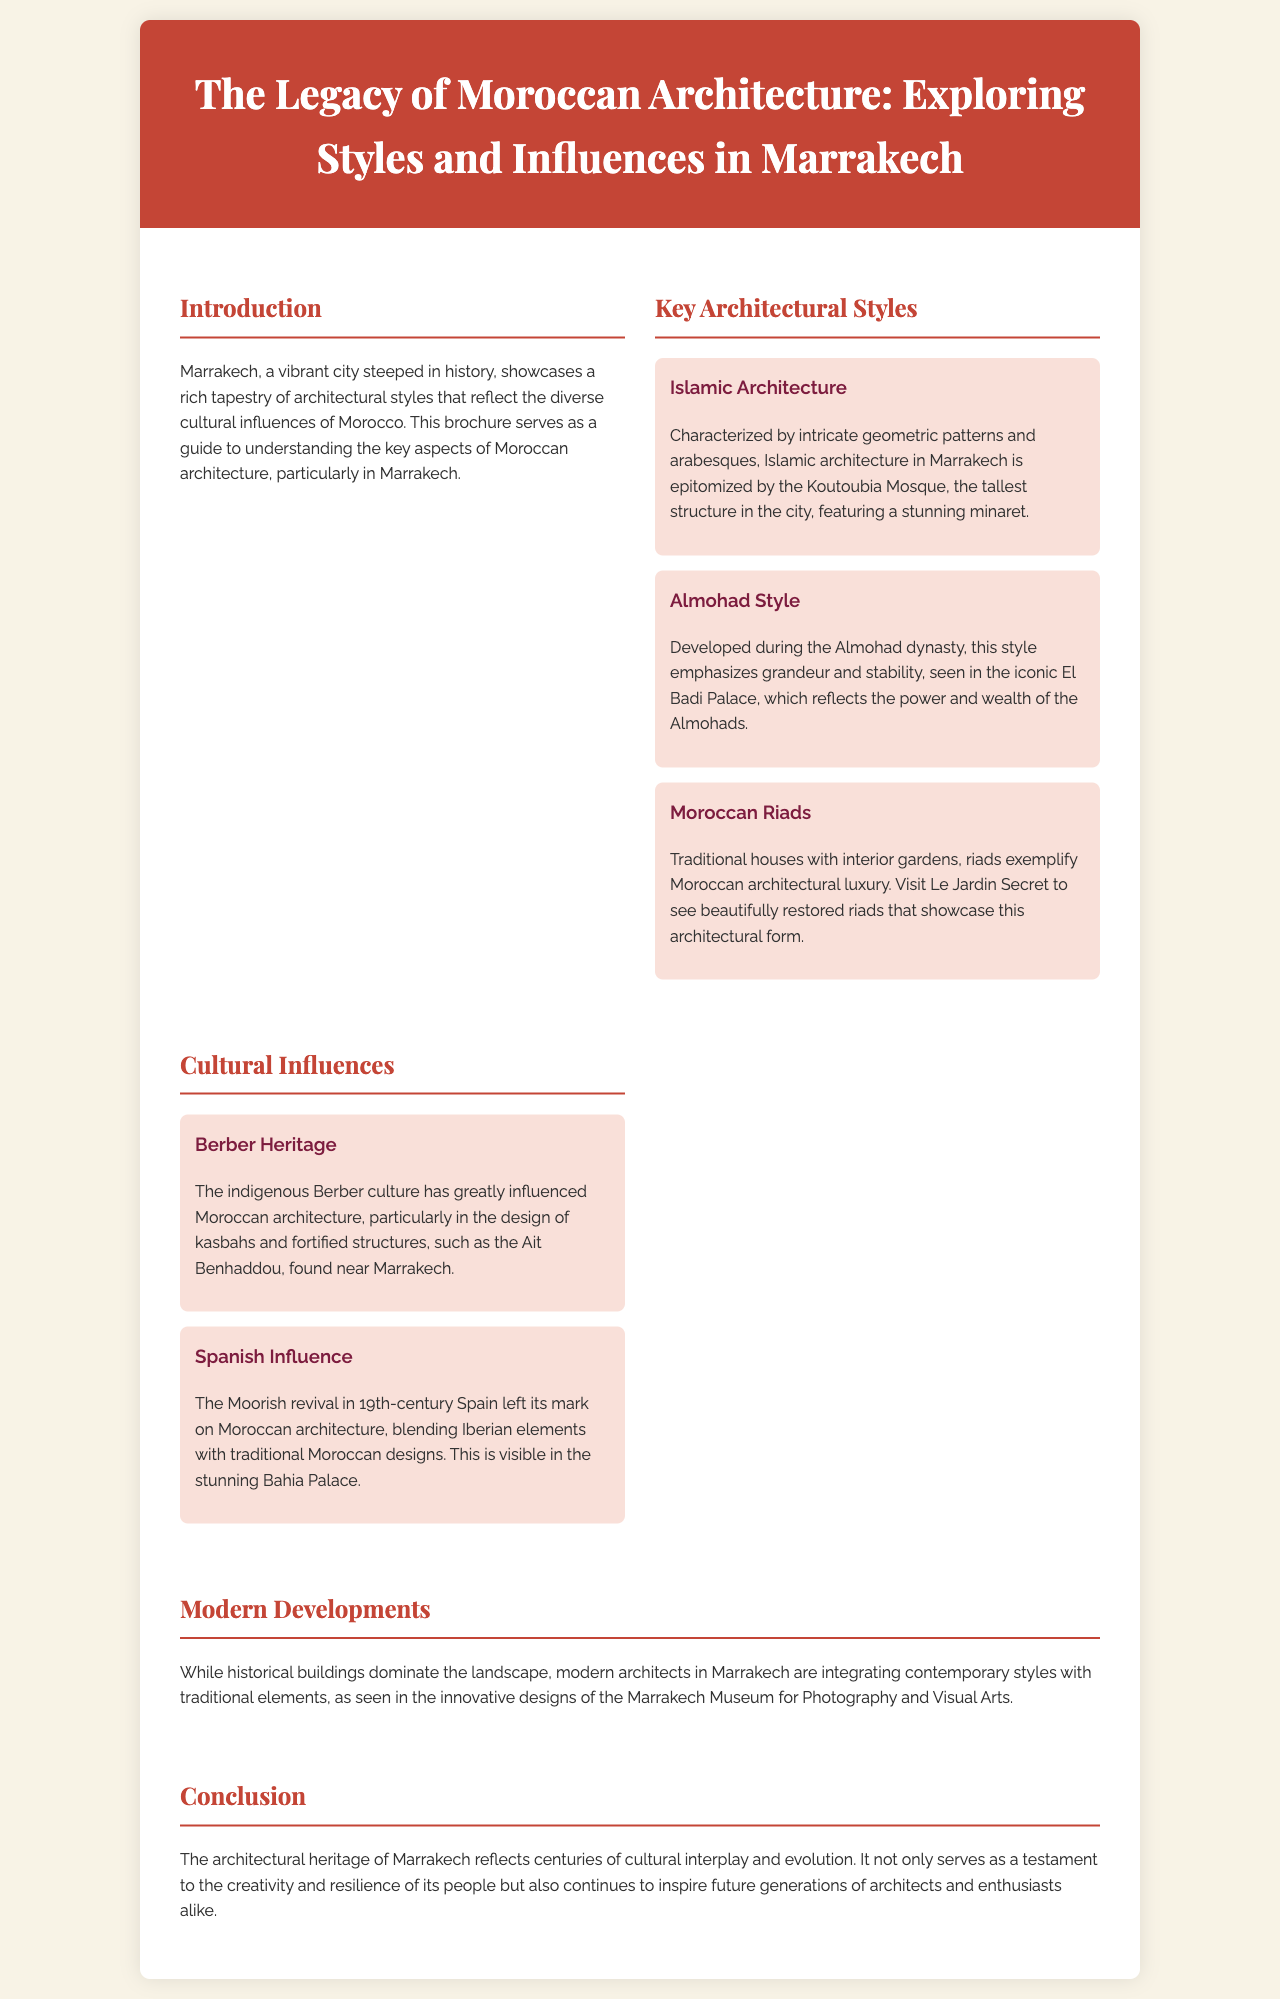What is the tallest structure in Marrakech? The tallest structure in Marrakech is the Koutoubia Mosque, which features a stunning minaret.
Answer: Koutoubia Mosque Which architectural style is characterized by intricate geometric patterns? The architectural style characterized by intricate geometric patterns is Islamic Architecture.
Answer: Islamic Architecture What palace reflects the power and wealth of the Almohads? The palace that reflects the power and wealth of the Almohads is the El Badi Palace.
Answer: El Badi Palace What traditional house style exemplifies Moroccan architectural luxury? The traditional house style that exemplifies Moroccan architectural luxury is riads.
Answer: Riads Which cultural heritage greatly influenced the design of kasbahs? The cultural heritage that greatly influenced the design of kasbahs is Berber Heritage.
Answer: Berber Heritage What is the modern architectural example mentioned that integrates contemporary styles in Marrakech? The modern architectural example that integrates contemporary styles is the Marrakech Museum for Photography and Visual Arts.
Answer: Marrakech Museum for Photography and Visual Arts What historic structure is noted for Spanish influence in Moroccan architecture? The historic structure noted for Spanish influence in Moroccan architecture is the Bahia Palace.
Answer: Bahia Palace How many key architectural styles are discussed in the document? The document discusses three key architectural styles in total.
Answer: Three What does the architectural heritage of Marrakech serve as a testament to? The architectural heritage of Marrakech serves as a testament to the creativity and resilience of its people.
Answer: Creativity and resilience of its people 